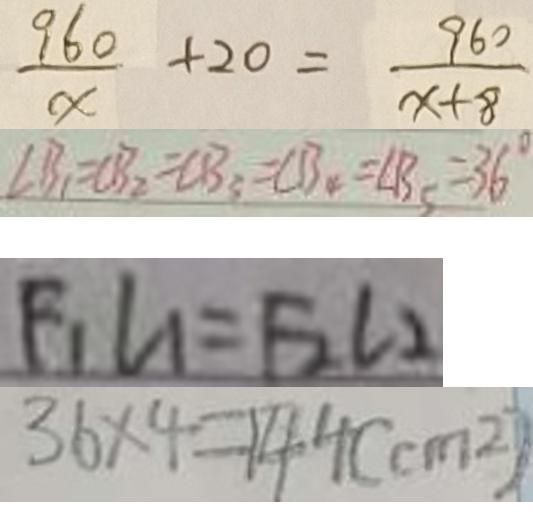Convert formula to latex. <formula><loc_0><loc_0><loc_500><loc_500>\frac { 9 6 0 } { x } + 2 0 = \frac { 9 6 0 } { x + 8 } 
 \angle B _ { 1 } = \angle B _ { 2 } = \angle B _ { 3 } = \angle B _ { 4 } = \angle B _ { 5 } = 3 6 ^ { \circ } 
 F _ { 1 } L _ { 1 } = F _ { 2 } L _ { 2 } 
 3 6 \times 4 = 1 4 4 ( c m ^ { 2 } )</formula> 